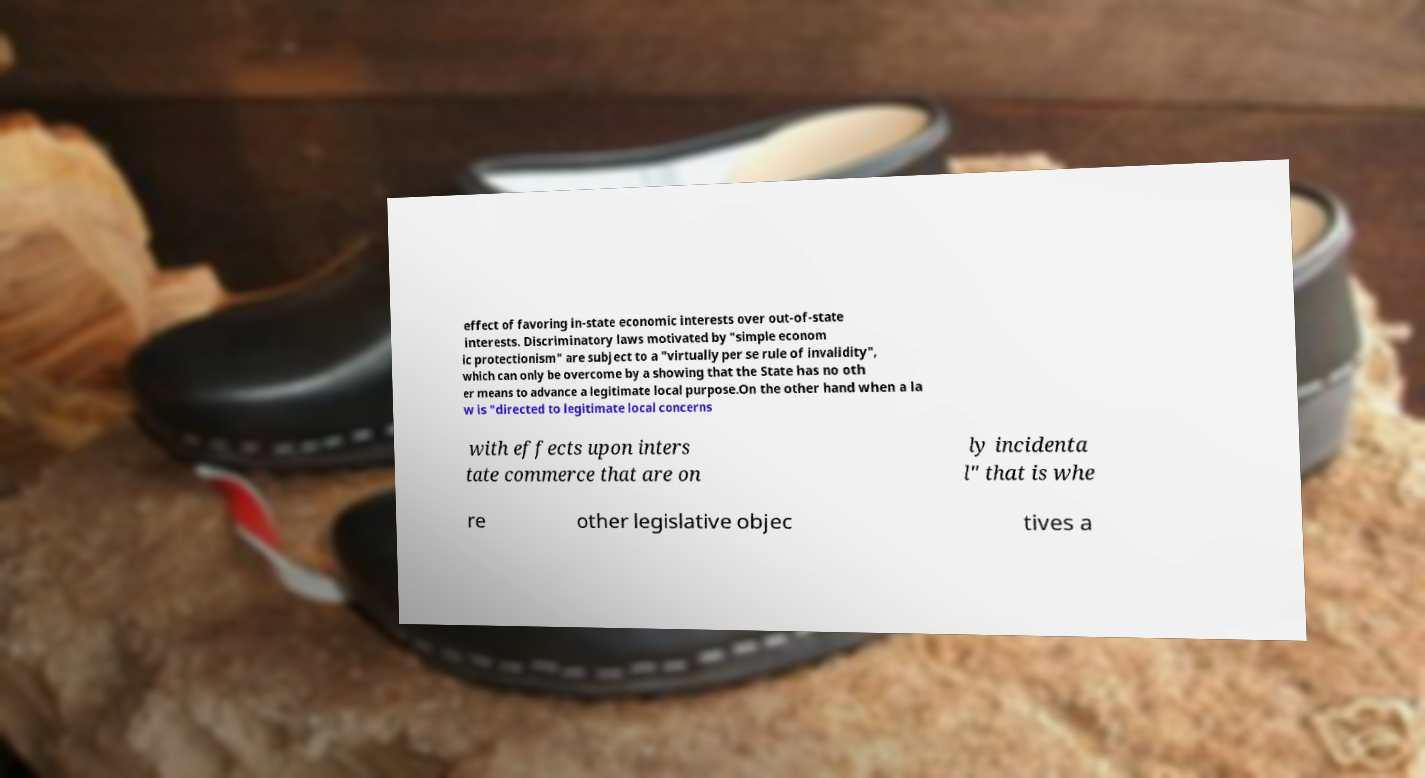Can you accurately transcribe the text from the provided image for me? effect of favoring in-state economic interests over out-of-state interests. Discriminatory laws motivated by "simple econom ic protectionism" are subject to a "virtually per se rule of invalidity", which can only be overcome by a showing that the State has no oth er means to advance a legitimate local purpose.On the other hand when a la w is "directed to legitimate local concerns with effects upon inters tate commerce that are on ly incidenta l" that is whe re other legislative objec tives a 